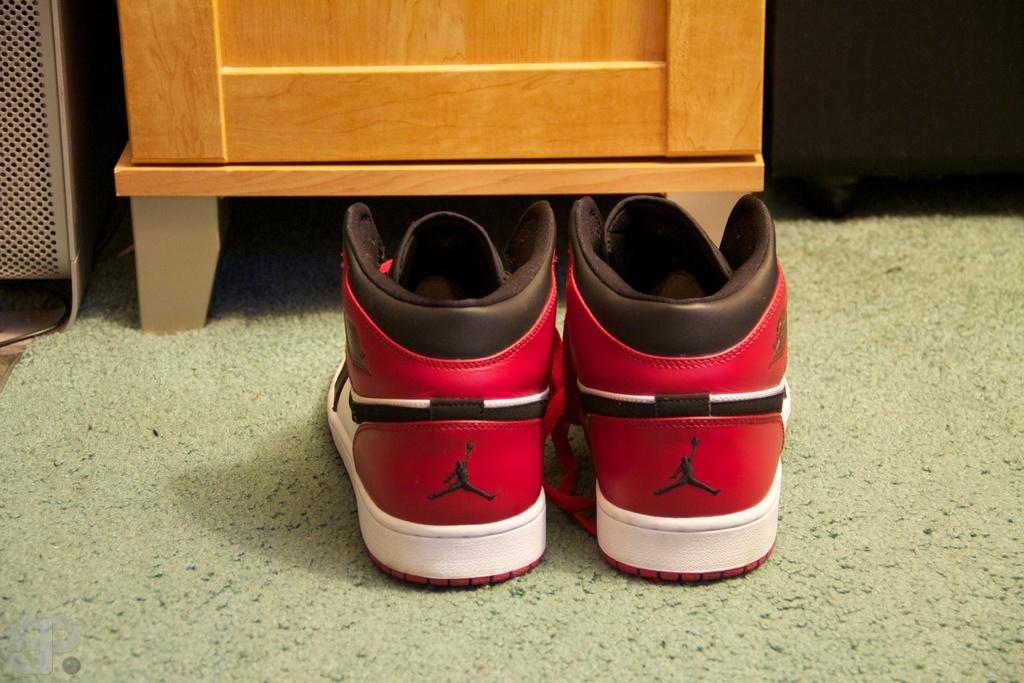What can be seen in the image? There is a pair of shoes in the image. Where are the shoes located? The shoes are on a carpet. What can be seen in the background of the image? There are cabinets in the background of the image. What type of tent is visible in the image? There is no tent present in the image; it features a pair of shoes on a carpet with cabinets in the background. 